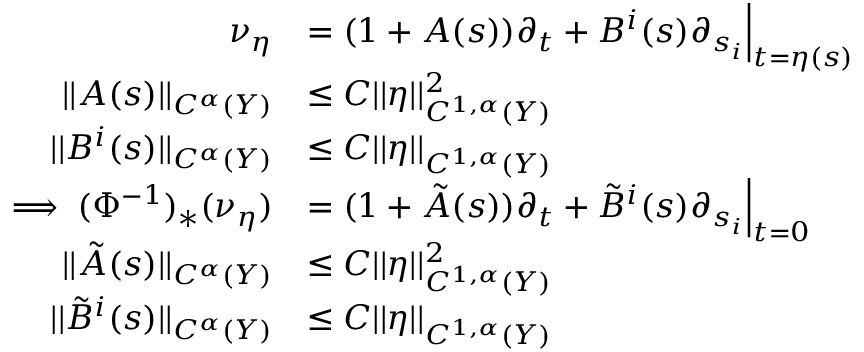<formula> <loc_0><loc_0><loc_500><loc_500>\begin{array} { r l } { \nu _ { \eta } } & { = ( 1 + A ( s ) ) \partial _ { t } + B ^ { i } ( s ) \partial _ { s _ { i } } \left | _ { t = \eta ( s ) } } \\ { | | A ( s ) | | _ { C ^ { \alpha } ( Y ) } } & { \leq C | | \eta | | _ { C ^ { 1 , \alpha } ( Y ) } ^ { 2 } } \\ { | | B ^ { i } ( s ) | | _ { C ^ { \alpha } ( Y ) } } & { \leq C | | \eta | | _ { C ^ { 1 , \alpha } ( Y ) } } \\ { \implies ( \Phi ^ { - 1 } ) _ { * } ( \nu _ { \eta } ) } & { = ( 1 + \tilde { A } ( s ) ) \partial _ { t } + \tilde { B } ^ { i } ( s ) \partial _ { s _ { i } } \right | _ { t = 0 } } \\ { | | \tilde { A } ( s ) | | _ { C ^ { \alpha } ( Y ) } } & { \leq C | | \eta | | _ { C ^ { 1 , \alpha } ( Y ) } ^ { 2 } } \\ { | | \tilde { B } ^ { i } ( s ) | | _ { C ^ { \alpha } ( Y ) } } & { \leq C | | \eta | | _ { C ^ { 1 , \alpha } ( Y ) } } \end{array}</formula> 